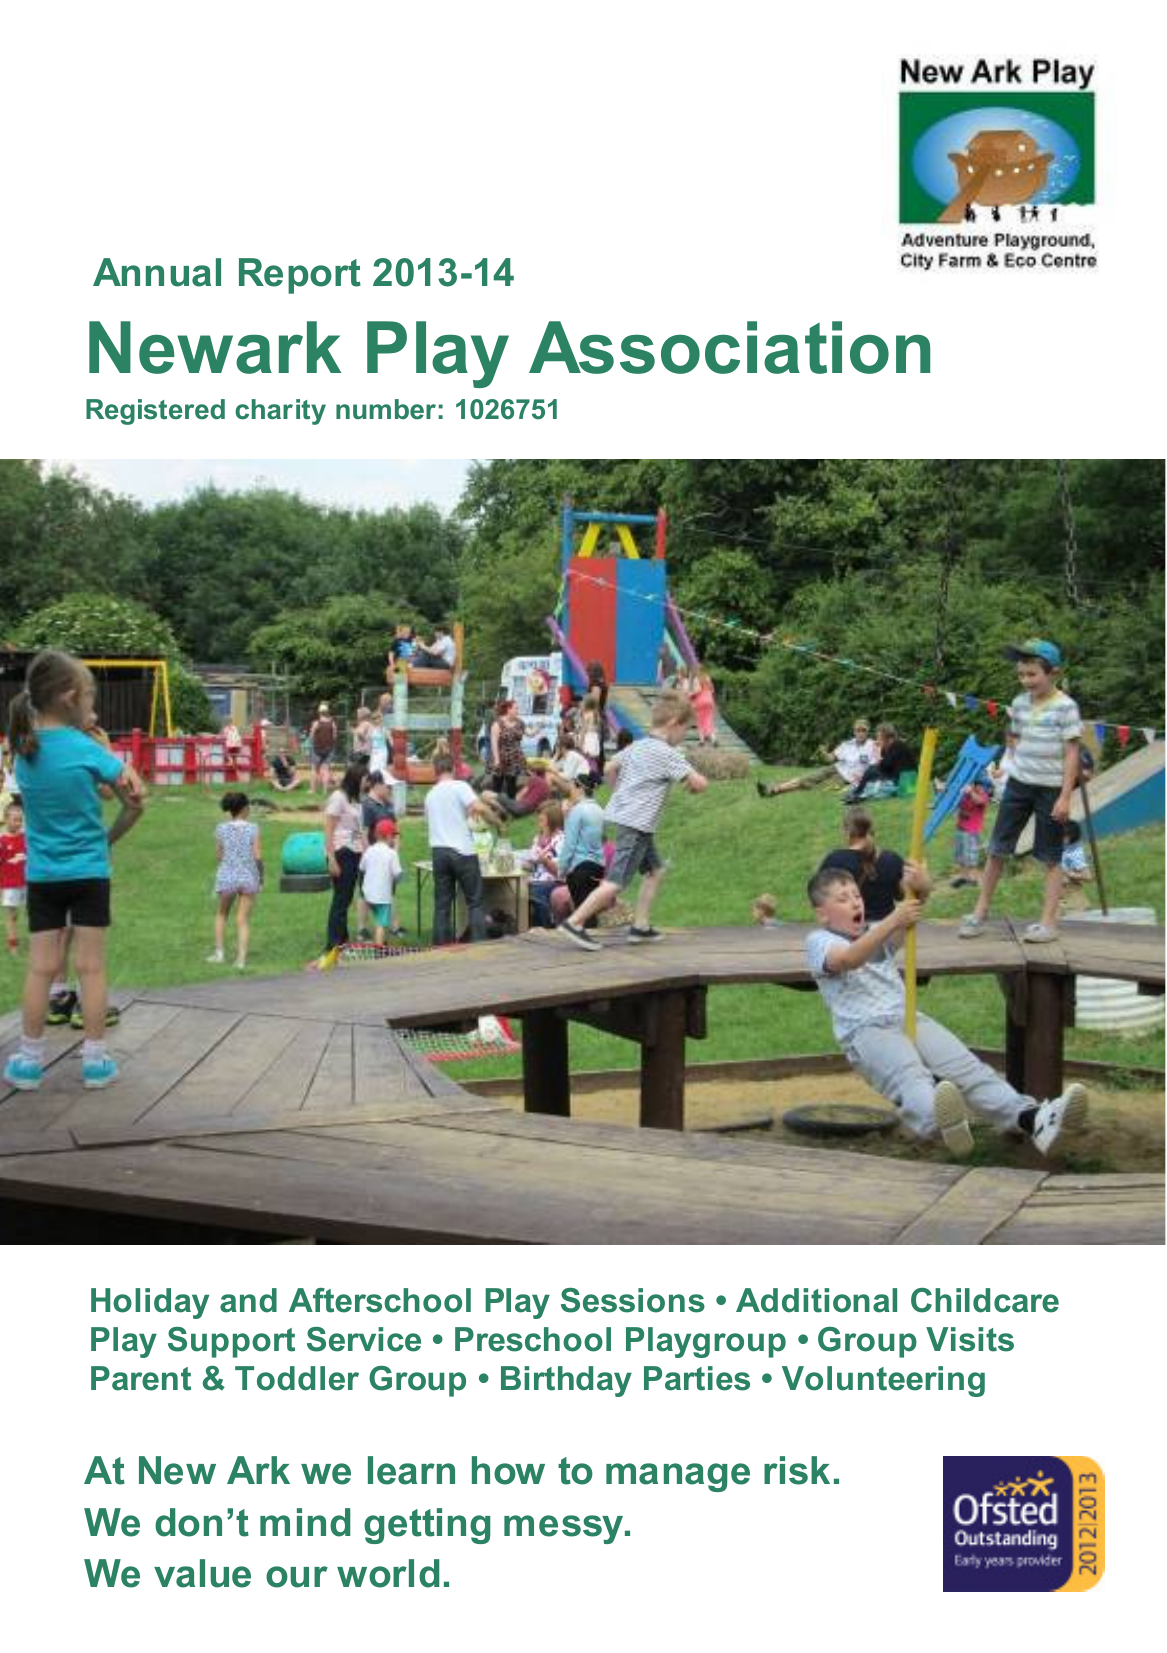What is the value for the spending_annually_in_british_pounds?
Answer the question using a single word or phrase. 262013.00 